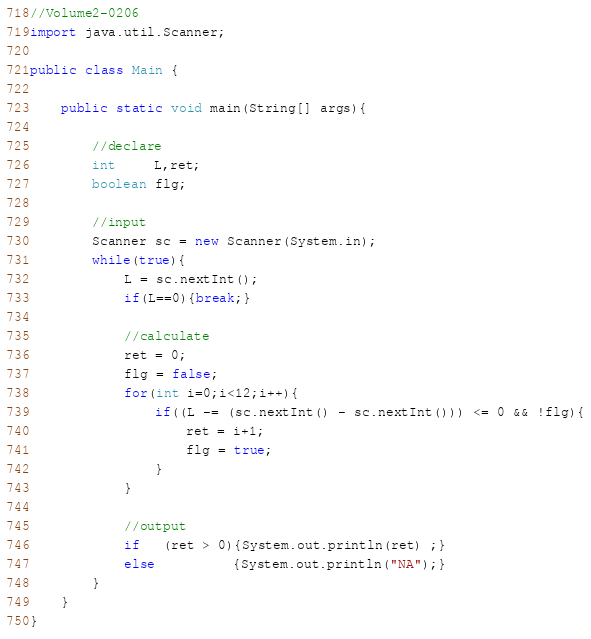Convert code to text. <code><loc_0><loc_0><loc_500><loc_500><_Java_>//Volume2-0206
import java.util.Scanner;

public class Main {

	public static void main(String[] args){

		//declare
		int     L,ret;
		boolean flg;

		//input
        Scanner sc = new Scanner(System.in);
        while(true){
            L = sc.nextInt();
            if(L==0){break;}

            //calculate
            ret = 0;
            flg = false;
            for(int i=0;i<12;i++){
            	if((L -= (sc.nextInt() - sc.nextInt())) <= 0 && !flg){
            		ret = i+1;
            		flg = true;
            	}
            }

            //output
            if   (ret > 0){System.out.println(ret) ;}
            else          {System.out.println("NA");}
        }
	}
}</code> 